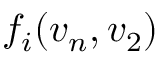Convert formula to latex. <formula><loc_0><loc_0><loc_500><loc_500>f _ { i } ( v _ { n } , v _ { 2 } )</formula> 